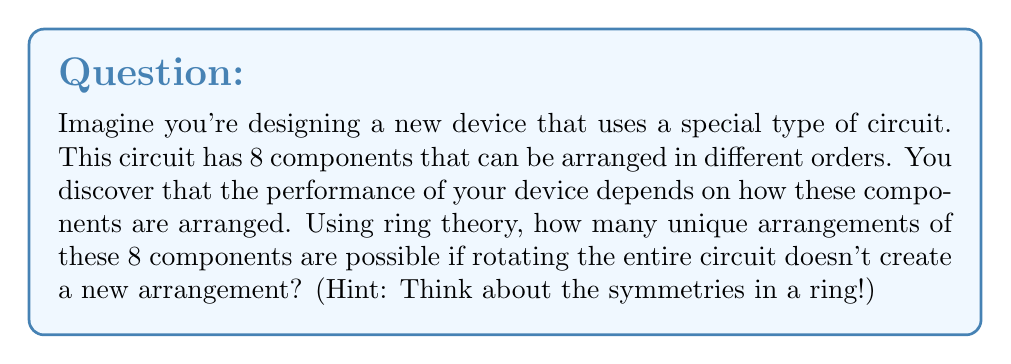Give your solution to this math problem. Let's approach this step-by-step using ring theory principles:

1) First, we need to recognize that this problem is related to cyclic groups, which are a fundamental concept in ring theory.

2) The circuit with 8 components can be thought of as elements arranged in a ring. The key here is that rotations of the entire ring don't create new arrangements.

3) In ring theory, this is equivalent to considering the cyclic group $C_8$, which has 8 elements.

4) However, we're not interested in all permutations of 8 elements (which would be 8!), but only those that are unique under rotation.

5) In group theory, these unique arrangements are called "necklaces" or "cyclic permutations".

6) The number of unique arrangements can be calculated using Burnside's lemma, which is a powerful tool in group theory.

7) For cyclic groups, there's a simpler formula derived from Burnside's lemma:

   $$N = \frac{1}{n}\sum_{d|n} \phi(d) \cdot n^{\frac{n}{d}}$$

   Where:
   $N$ is the number of unique arrangements
   $n$ is the number of elements (8 in this case)
   $d$ are the divisors of $n$
   $\phi(d)$ is Euler's totient function

8) For $n=8$, the divisors are 1, 2, 4, and 8.

9) Calculating $\phi(d)$ for each divisor:
   $\phi(1) = 1$
   $\phi(2) = 1$
   $\phi(4) = 2$
   $\phi(8) = 4$

10) Plugging into the formula:

    $$N = \frac{1}{8}(1 \cdot 8^8 + 1 \cdot 8^4 + 2 \cdot 8^2 + 4 \cdot 8^1)$$

11) Simplifying:

    $$N = \frac{1}{8}(16777216 + 4096 + 128 + 32) = 2097184$$

Therefore, there are 2,097,184 unique arrangements of the 8 components in the circuit.
Answer: 2,097,184 unique arrangements 